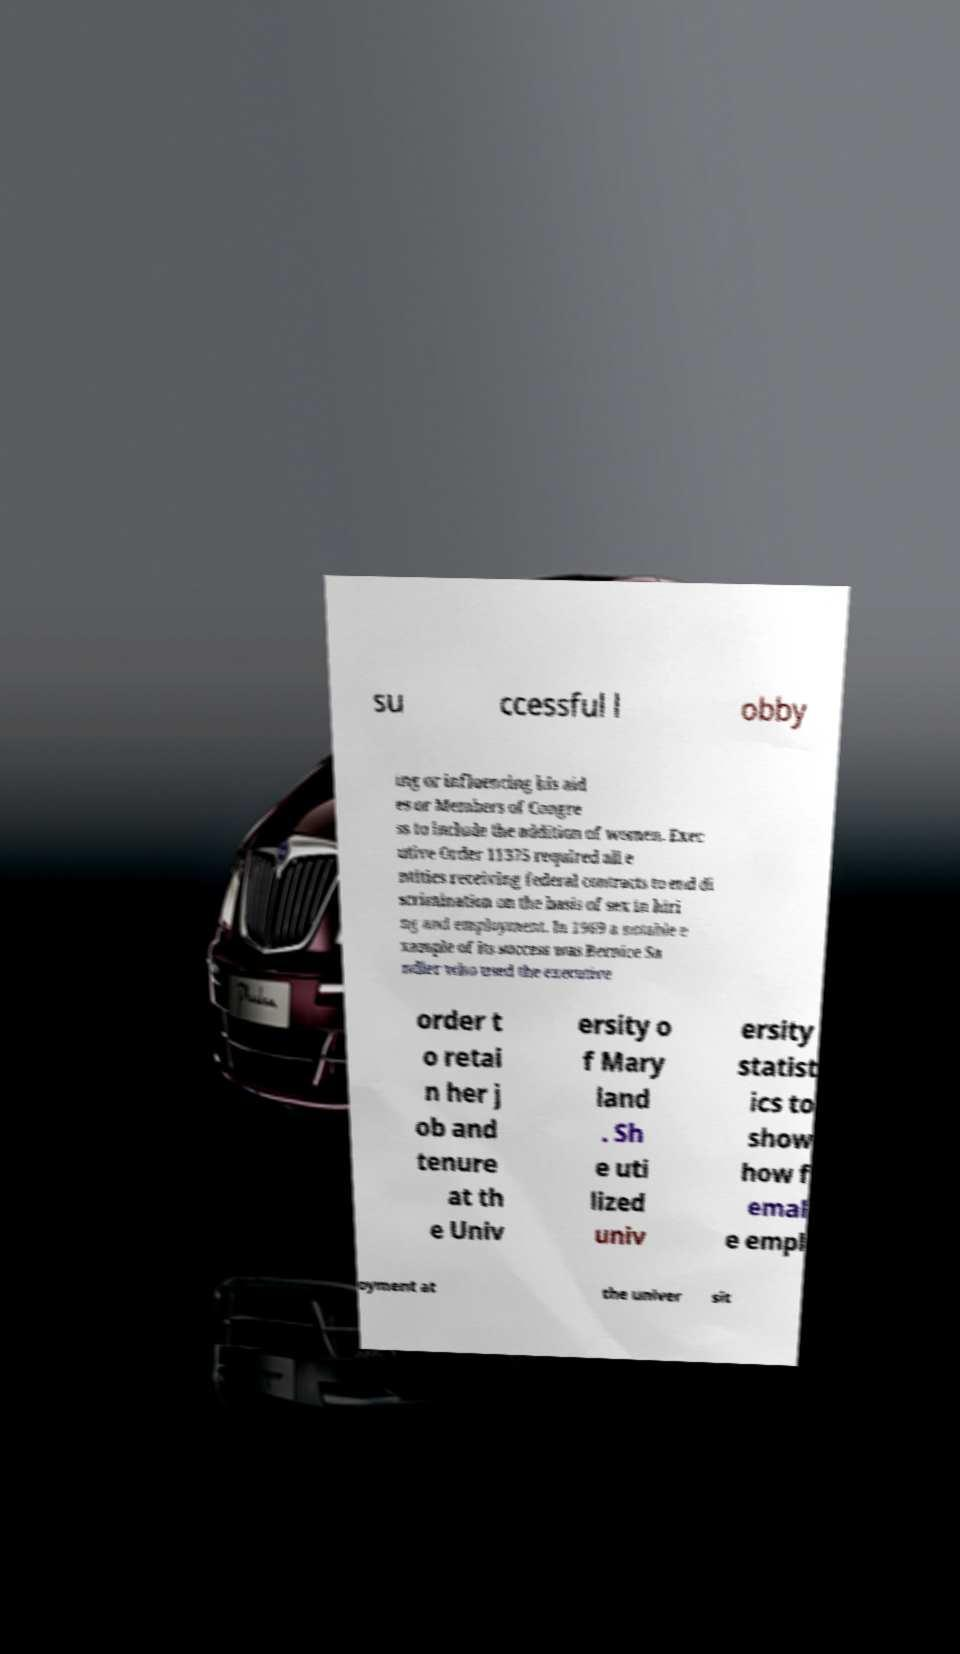Can you read and provide the text displayed in the image?This photo seems to have some interesting text. Can you extract and type it out for me? su ccessful l obby ing or influencing his aid es or Members of Congre ss to include the addition of women. Exec utive Order 11375 required all e ntities receiving federal contracts to end di scrimination on the basis of sex in hiri ng and employment. In 1969 a notable e xample of its success was Bernice Sa ndler who used the executive order t o retai n her j ob and tenure at th e Univ ersity o f Mary land . Sh e uti lized univ ersity statist ics to show how f emal e empl oyment at the univer sit 